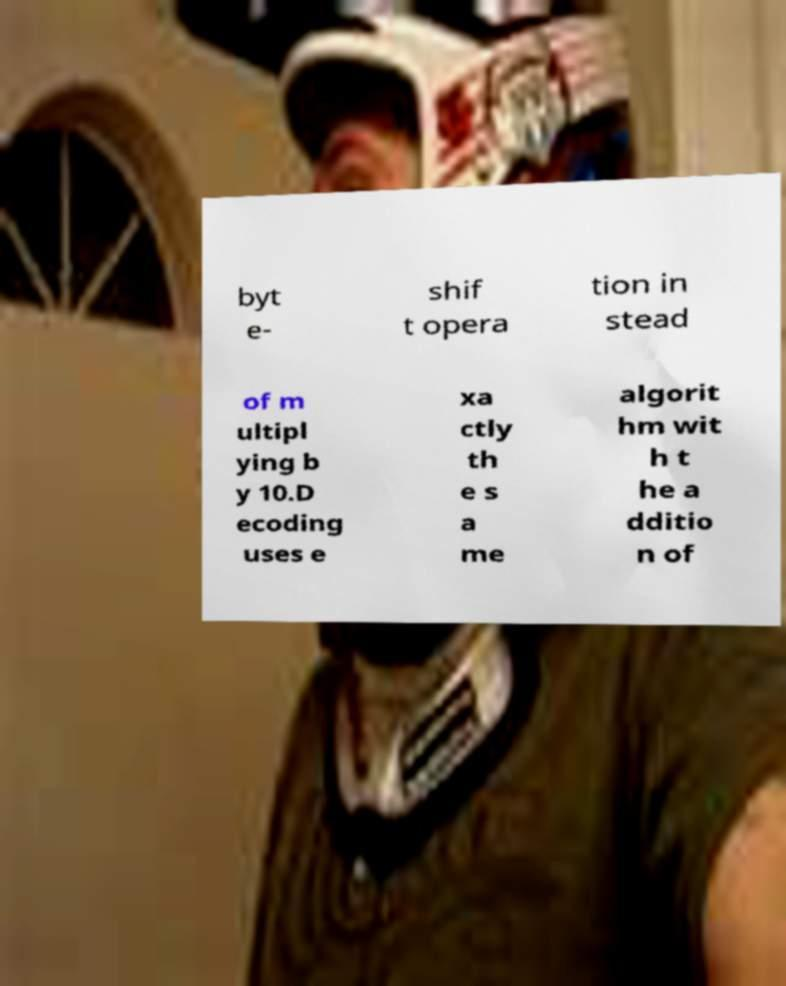Please identify and transcribe the text found in this image. byt e- shif t opera tion in stead of m ultipl ying b y 10.D ecoding uses e xa ctly th e s a me algorit hm wit h t he a dditio n of 